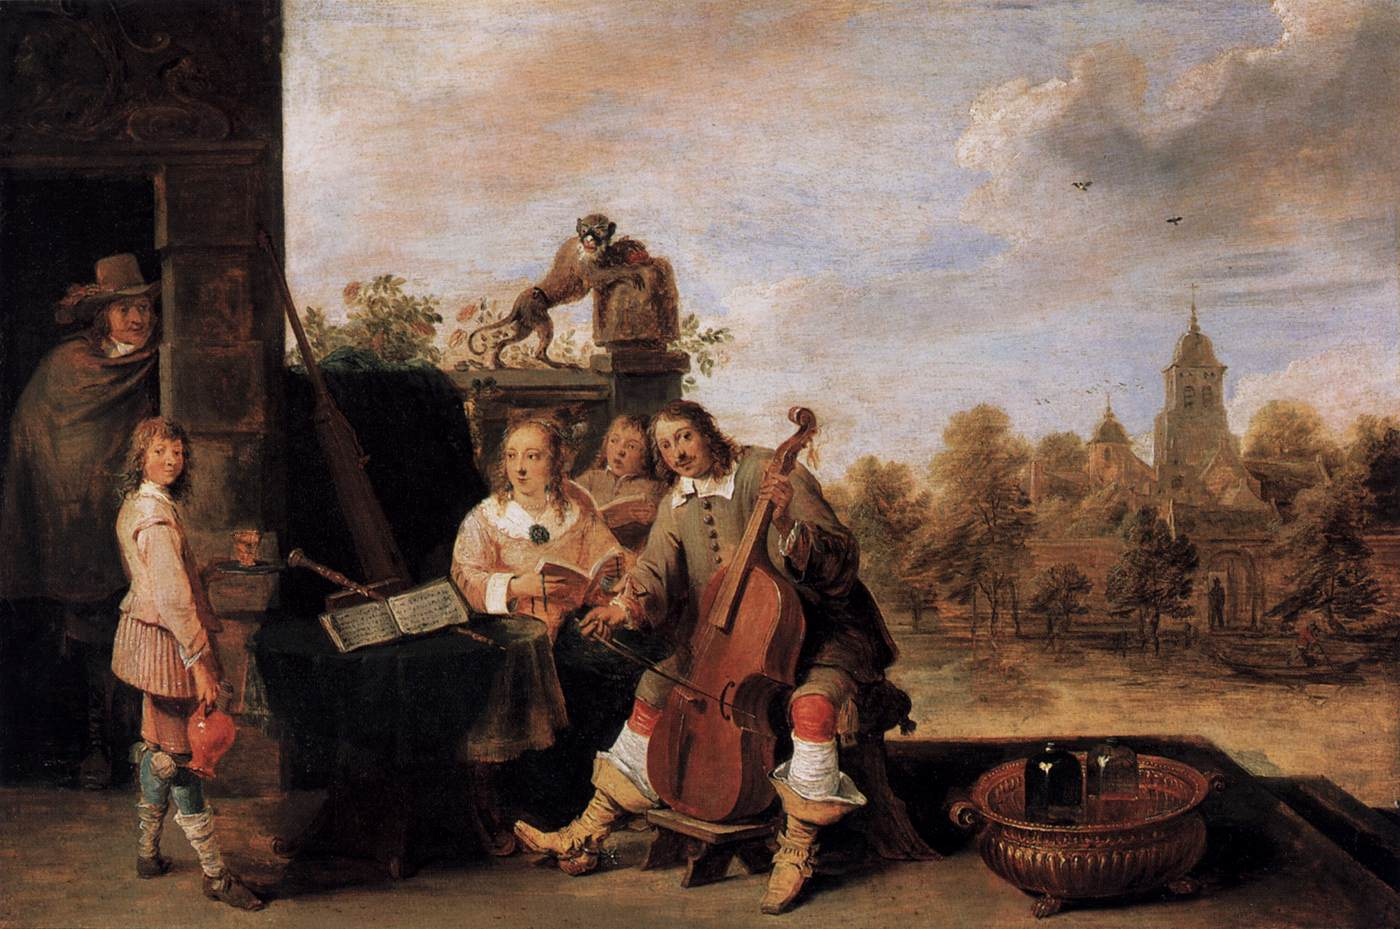What might this scene convey about the culture or period it represents? The scene captured in this painting likely aims to represent a slice of cultural life from the time, emphasizing leisure, music, and communal gatherings. The outdoor setting, near what appears to be a village or church, implies that this might be a special occasion, such as a local market day, festival, or communal celebration. The activity of making music together in a public space was a common leisurely pursuit, hinting at a society that valued artistic expression and community bonds. The overall atmosphere is one of harmony and cultural richness, which would have resonated with viewers from the period, highlighting values of the time, such as the appreciation for aesthetics, social cohesion, and the joy found in everyday life. 